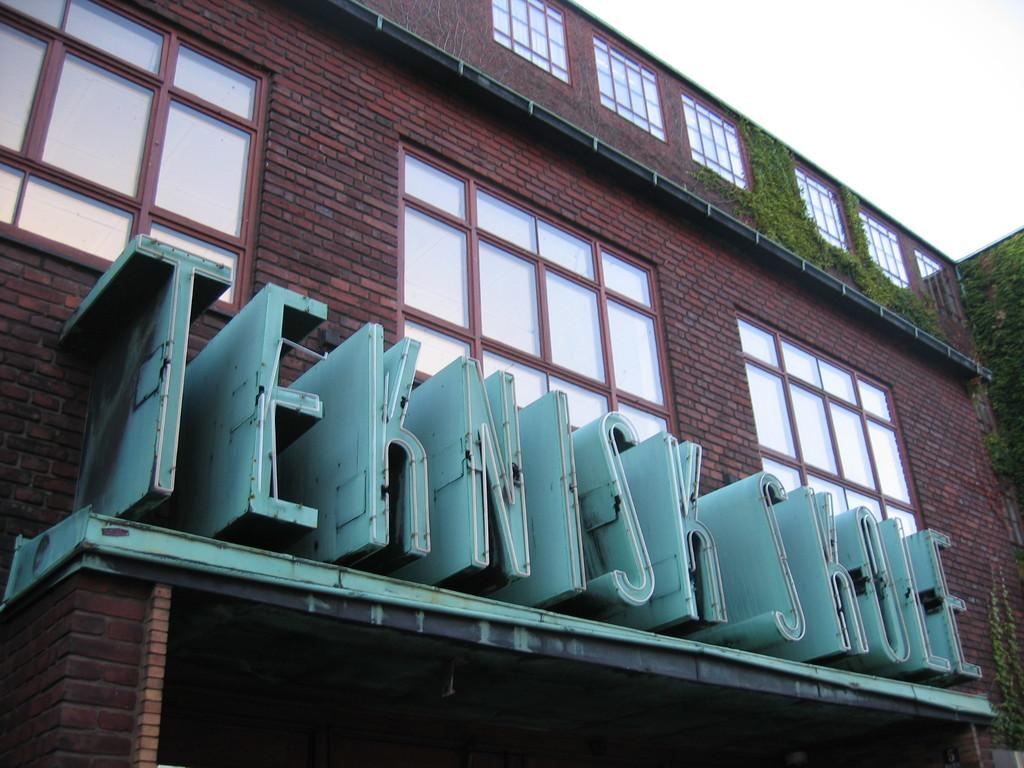What type of structure is present in the image? There is a building in the image. What material is used for the walls of the building? The building has brick walls. What architectural features can be seen on the building? The building has windows. What else is present in the image besides the building? There are plants, text, and objects visible in the image. What is visible at the top right side of the image? The sky is visible at the top right side of the image. How many seeds are visible in the image? There are no seeds present in the image. What type of drink is being served in the image? There is no drink visible in the image. 